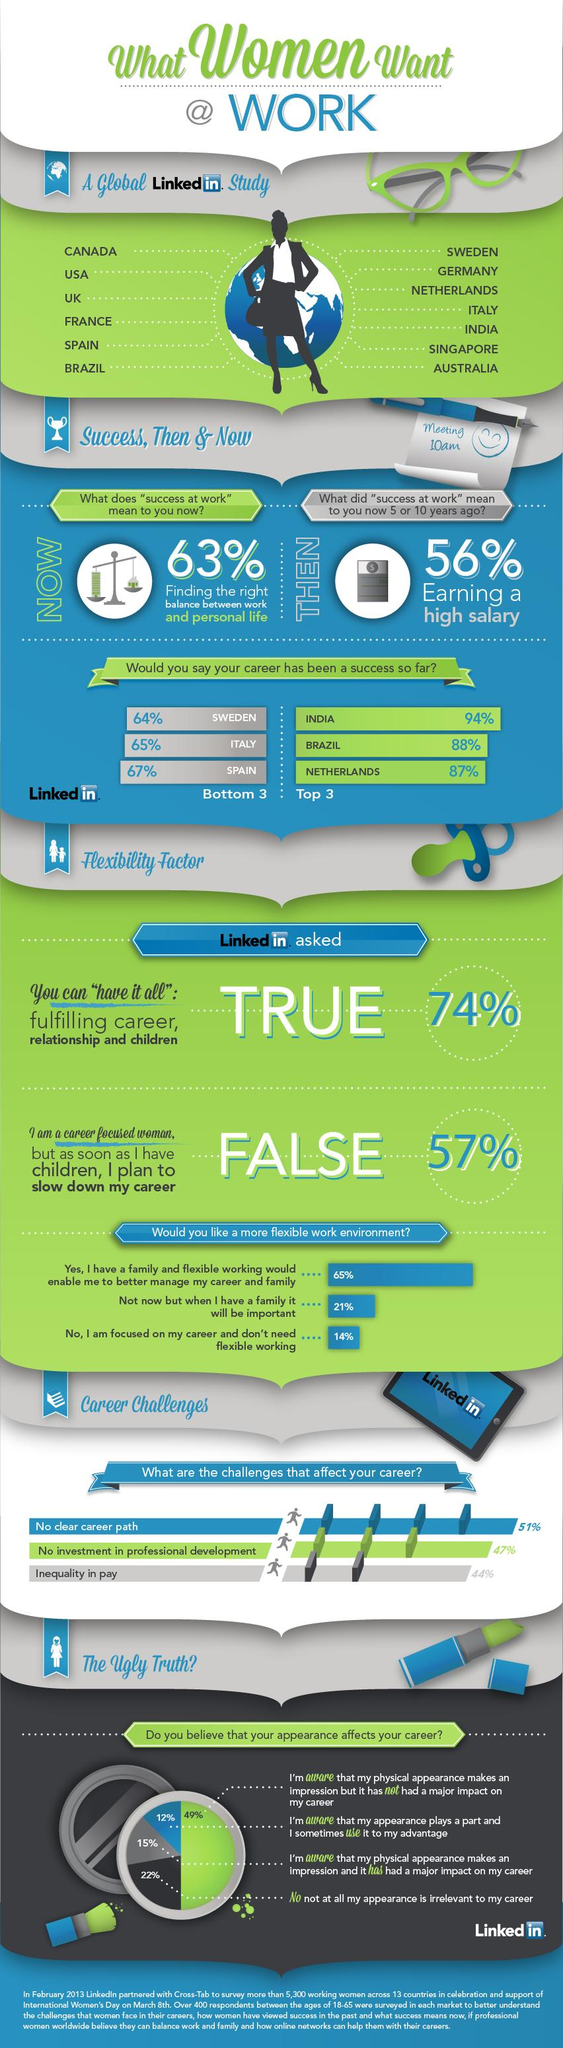Identify some key points in this picture. The LinkedIn study included 13 countries. Success at work now means achieving the appropriate balance between work and personal life, as it is essential to maintain a healthy and fulfilling lifestyle. In the past, success at work was defined as earning a high salary. According to the survey, 26% of people believe that it is impossible to have it all, which includes a fulfilling career, a successful relationship, and children. According to a recent survey, 43% of women have stated that they plan to slow down their career after having children. 